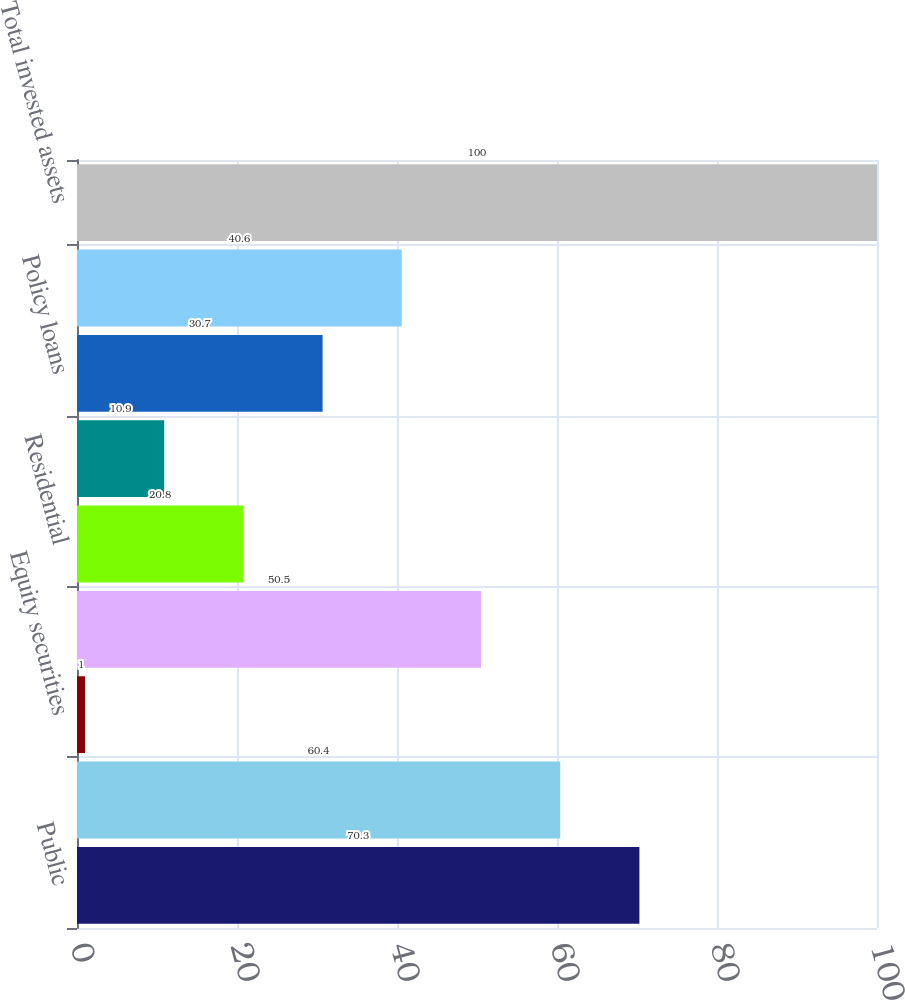Convert chart to OTSL. <chart><loc_0><loc_0><loc_500><loc_500><bar_chart><fcel>Public<fcel>Private<fcel>Equity securities<fcel>Commercial<fcel>Residential<fcel>Real estate held for<fcel>Policy loans<fcel>Other investments<fcel>Total invested assets<nl><fcel>70.3<fcel>60.4<fcel>1<fcel>50.5<fcel>20.8<fcel>10.9<fcel>30.7<fcel>40.6<fcel>100<nl></chart> 